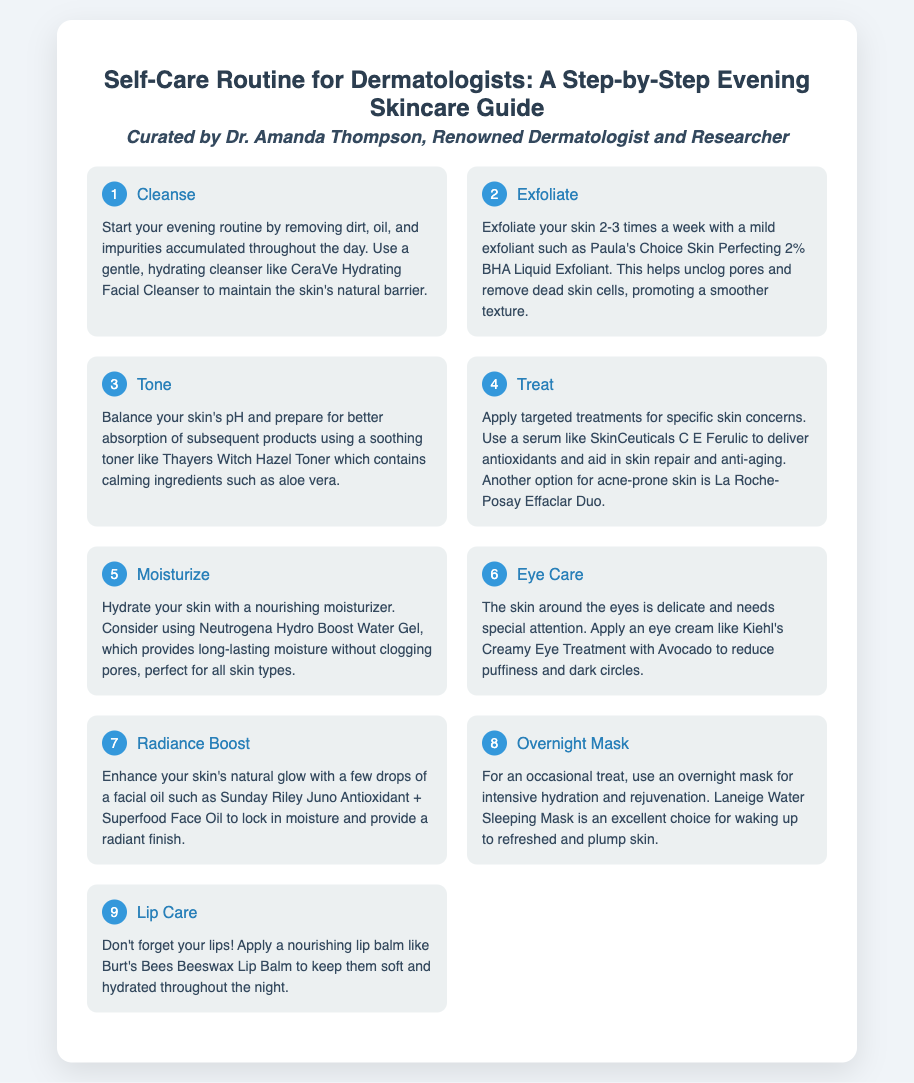What is the title of the guide? The title of the guide is presented in the document and identifies the content's focus on dermatologists' self-care.
Answer: Self-Care Routine for Dermatologists: A Step-by-Step Evening Skincare Guide Who curated the skincare guide? The document credits a specific individual for curating the guide, highlighting their expertise.
Answer: Dr. Amanda Thompson What is the first step in the skincare routine? The first step in the evening skincare routine is outlined at the top of the list of steps.
Answer: Cleanse Which product is recommended for cleansing? A specific product is mentioned as a recommendation for cleansing in the first step.
Answer: CeraVe Hydrating Facial Cleanser How many times a week should you exfoliate? The exfoliation frequency is detailed in the second step, providing guidance on how often it should be done.
Answer: 2-3 times What should you apply after toning? The logical sequence in the guide suggests a follow-up action after toning, aimed at addressing specific concerns.
Answer: Treat What is the purpose of a moisturizer in this routine? The document explains the role of moisturizer in the skincare routine, identifying its primary benefit.
Answer: Hydrate Which eye cream is recommended? The guide suggests a specific product for eye care, indicating its targeted benefits.
Answer: Kiehl's Creamy Eye Treatment with Avocado What product is mentioned for overnight hydration? In the context of the routine, a product is specified for intensive overnight benefits.
Answer: Laneige Water Sleeping Mask 